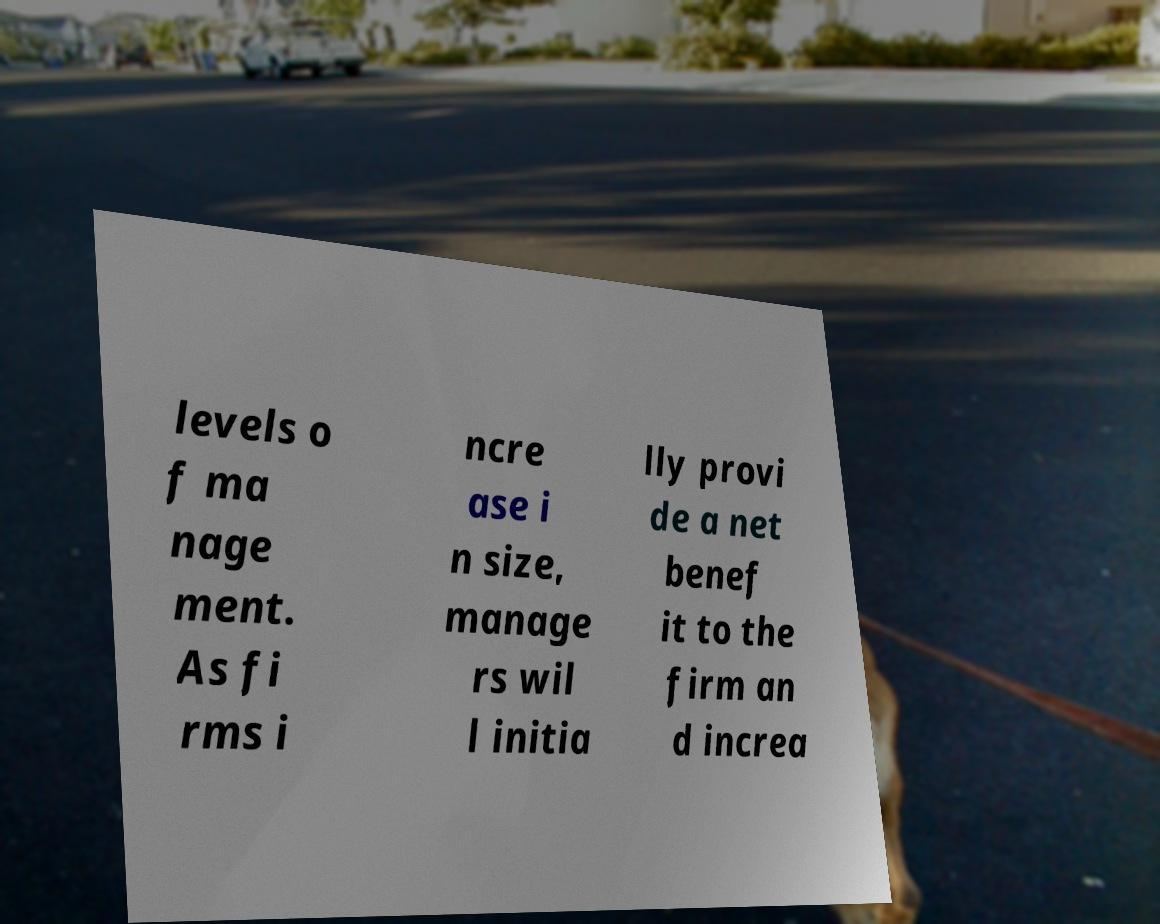I need the written content from this picture converted into text. Can you do that? levels o f ma nage ment. As fi rms i ncre ase i n size, manage rs wil l initia lly provi de a net benef it to the firm an d increa 